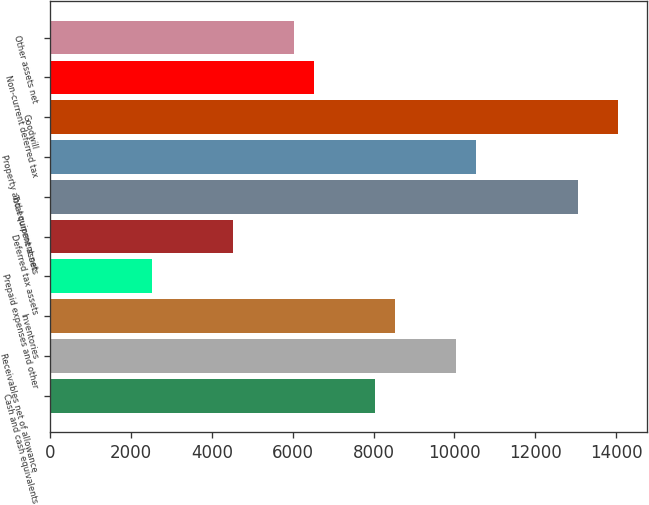Convert chart. <chart><loc_0><loc_0><loc_500><loc_500><bar_chart><fcel>Cash and cash equivalents<fcel>Receivables net of allowance<fcel>Inventories<fcel>Prepaid expenses and other<fcel>Deferred tax assets<fcel>Total current assets<fcel>Property and equipment net<fcel>Goodwill<fcel>Non-current deferred tax<fcel>Other assets net<nl><fcel>8032.9<fcel>10040.9<fcel>8534.9<fcel>2510.9<fcel>4518.9<fcel>13052.9<fcel>10542.9<fcel>14056.9<fcel>6526.9<fcel>6024.9<nl></chart> 